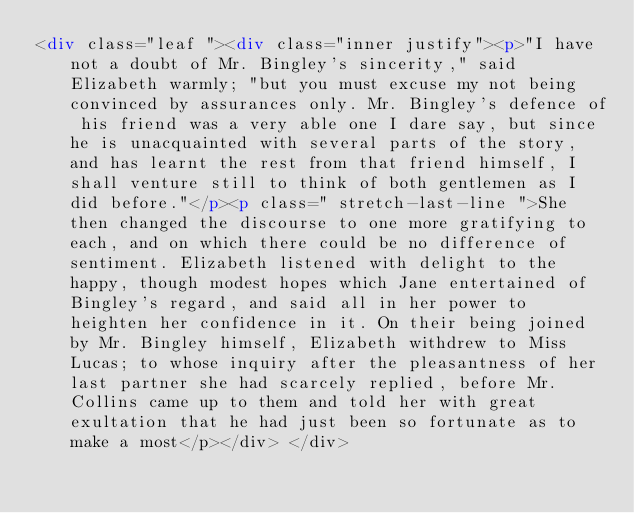Convert code to text. <code><loc_0><loc_0><loc_500><loc_500><_HTML_><div class="leaf "><div class="inner justify"><p>"I have not a doubt of Mr. Bingley's sincerity," said Elizabeth warmly; "but you must excuse my not being convinced by assurances only. Mr. Bingley's defence of his friend was a very able one I dare say, but since he is unacquainted with several parts of the story, and has learnt the rest from that friend himself, I shall venture still to think of both gentlemen as I did before."</p><p class=" stretch-last-line ">She then changed the discourse to one more gratifying to each, and on which there could be no difference of sentiment. Elizabeth listened with delight to the happy, though modest hopes which Jane entertained of Bingley's regard, and said all in her power to heighten her confidence in it. On their being joined by Mr. Bingley himself, Elizabeth withdrew to Miss Lucas; to whose inquiry after the pleasantness of her last partner she had scarcely replied, before Mr. Collins came up to them and told her with great exultation that he had just been so fortunate as to make a most</p></div> </div></code> 